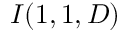<formula> <loc_0><loc_0><loc_500><loc_500>I ( 1 , 1 , D )</formula> 